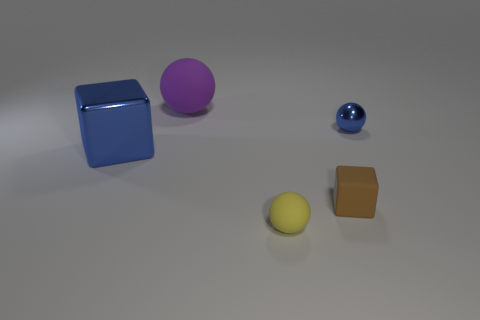Add 1 matte cubes. How many objects exist? 6 Subtract all metal spheres. How many spheres are left? 2 Subtract all blue balls. How many balls are left? 2 Subtract all balls. How many objects are left? 2 Subtract all large shiny things. Subtract all small balls. How many objects are left? 2 Add 4 small rubber spheres. How many small rubber spheres are left? 5 Add 3 large cyan things. How many large cyan things exist? 3 Subtract 0 green blocks. How many objects are left? 5 Subtract 1 blocks. How many blocks are left? 1 Subtract all cyan cubes. Subtract all green balls. How many cubes are left? 2 